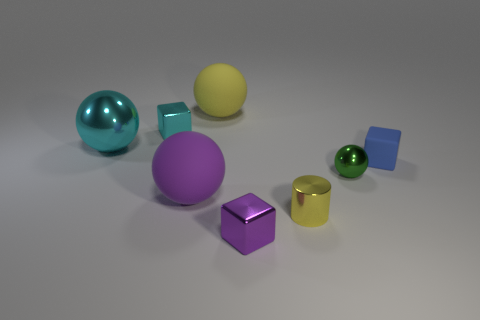How big is the yellow thing that is behind the big purple object? The yellow object appears to be a small spherical ball, significantly smaller in size than the big purple sphere in the foreground. 